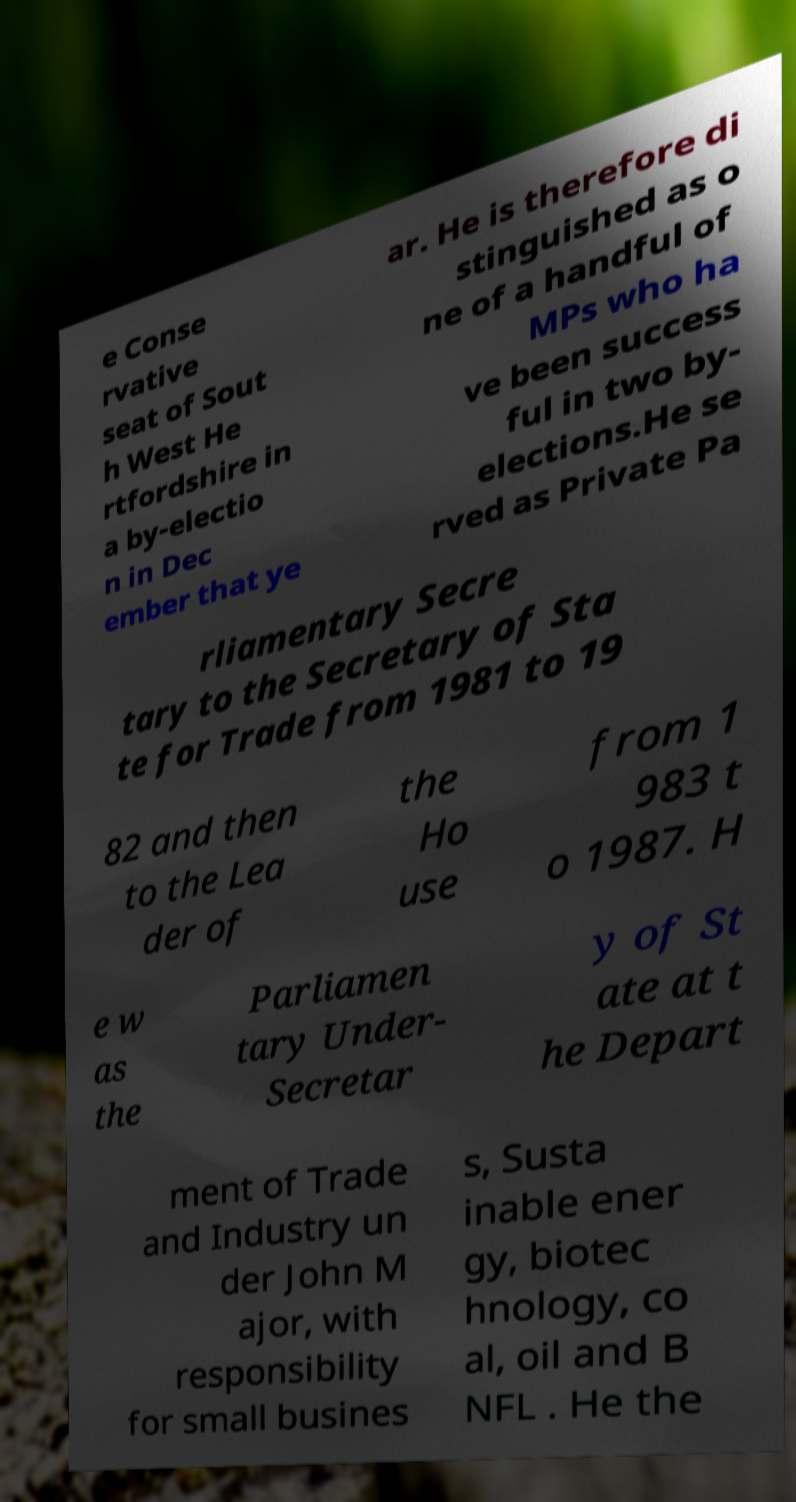Please read and relay the text visible in this image. What does it say? e Conse rvative seat of Sout h West He rtfordshire in a by-electio n in Dec ember that ye ar. He is therefore di stinguished as o ne of a handful of MPs who ha ve been success ful in two by- elections.He se rved as Private Pa rliamentary Secre tary to the Secretary of Sta te for Trade from 1981 to 19 82 and then to the Lea der of the Ho use from 1 983 t o 1987. H e w as the Parliamen tary Under- Secretar y of St ate at t he Depart ment of Trade and Industry un der John M ajor, with responsibility for small busines s, Susta inable ener gy, biotec hnology, co al, oil and B NFL . He the 